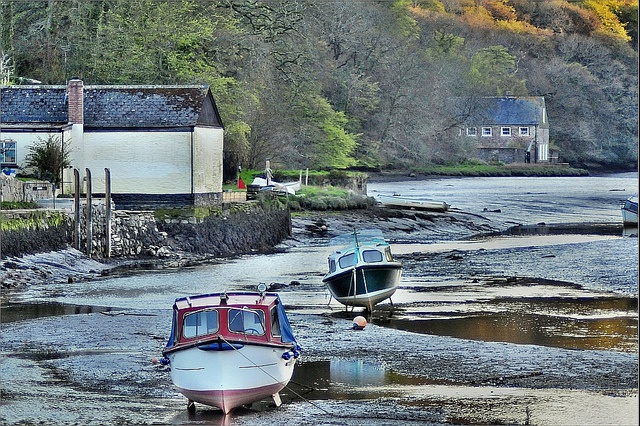Describe the objects in this image and their specific colors. I can see boat in gray, lightblue, black, and lightgray tones, boat in gray, black, and lightgray tones, and boat in gray, black, darkgray, and navy tones in this image. 